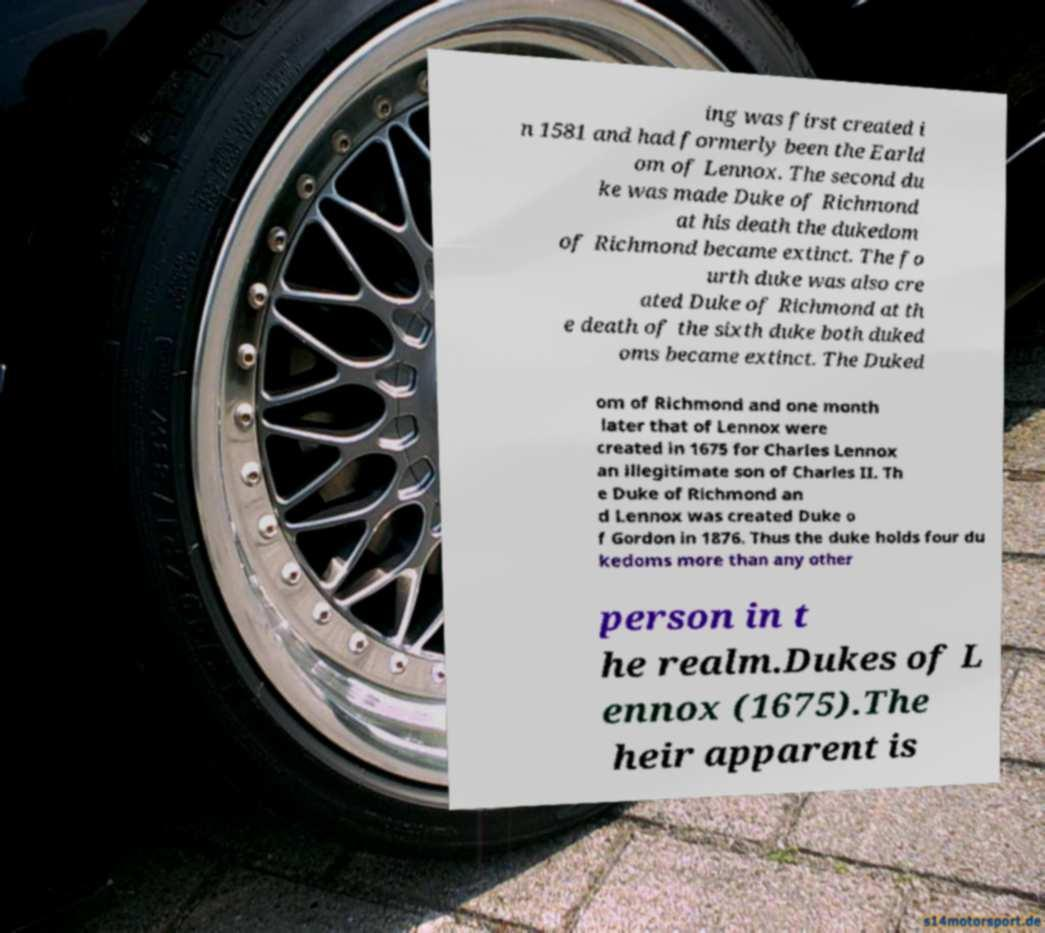There's text embedded in this image that I need extracted. Can you transcribe it verbatim? ing was first created i n 1581 and had formerly been the Earld om of Lennox. The second du ke was made Duke of Richmond at his death the dukedom of Richmond became extinct. The fo urth duke was also cre ated Duke of Richmond at th e death of the sixth duke both duked oms became extinct. The Duked om of Richmond and one month later that of Lennox were created in 1675 for Charles Lennox an illegitimate son of Charles II. Th e Duke of Richmond an d Lennox was created Duke o f Gordon in 1876. Thus the duke holds four du kedoms more than any other person in t he realm.Dukes of L ennox (1675).The heir apparent is 